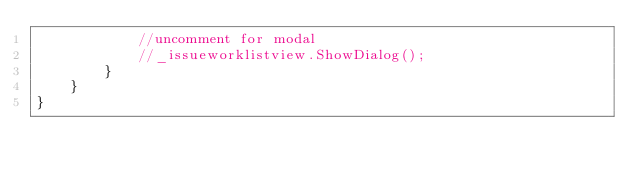Convert code to text. <code><loc_0><loc_0><loc_500><loc_500><_C#_>			//uncomment for modal
			//_issueworklistview.ShowDialog();
		}
	}
}
</code> 